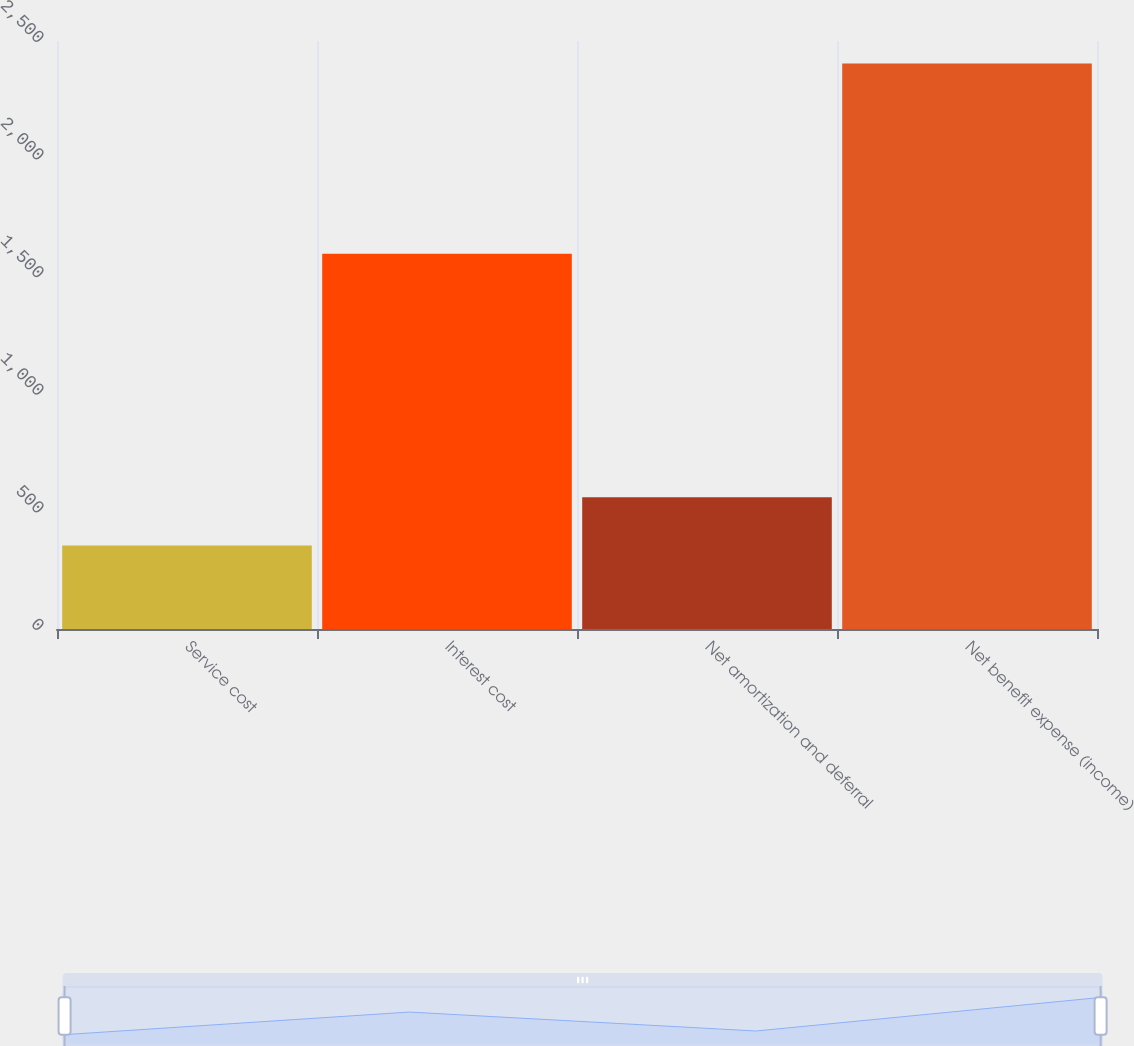Convert chart to OTSL. <chart><loc_0><loc_0><loc_500><loc_500><bar_chart><fcel>Service cost<fcel>Interest cost<fcel>Net amortization and deferral<fcel>Net benefit expense (income)<nl><fcel>355<fcel>1595<fcel>559.9<fcel>2404<nl></chart> 